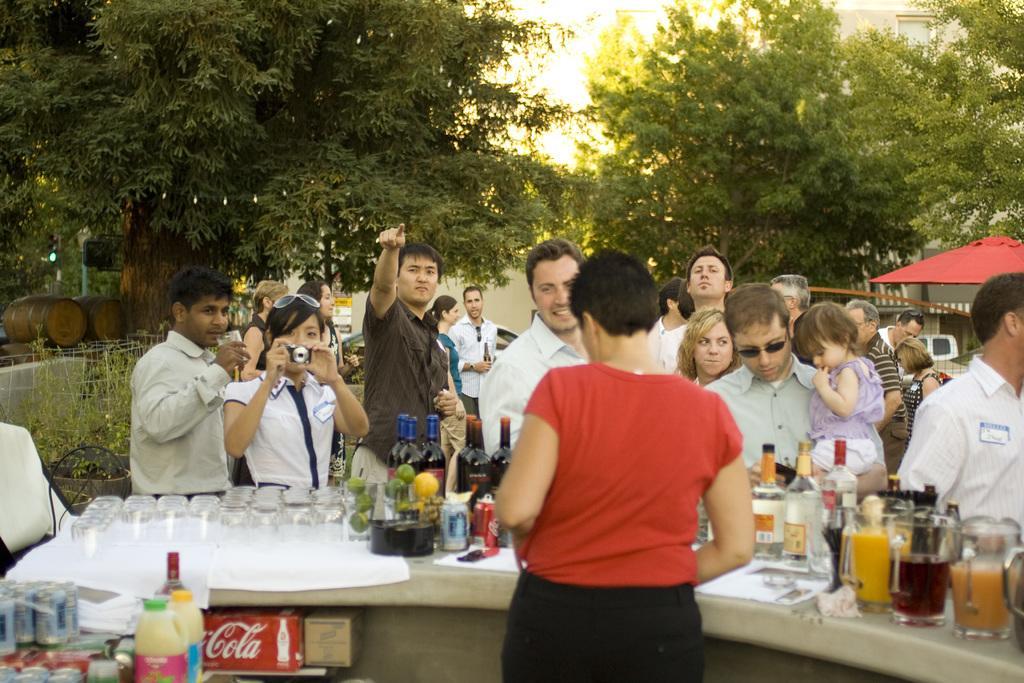In one or two sentences, can you explain what this image depicts? This picture shows a group of people standing and a woman holding a camera and taking a picture and we see other women standing and serving and we see few glasses,bottles on the table and we see trees around 